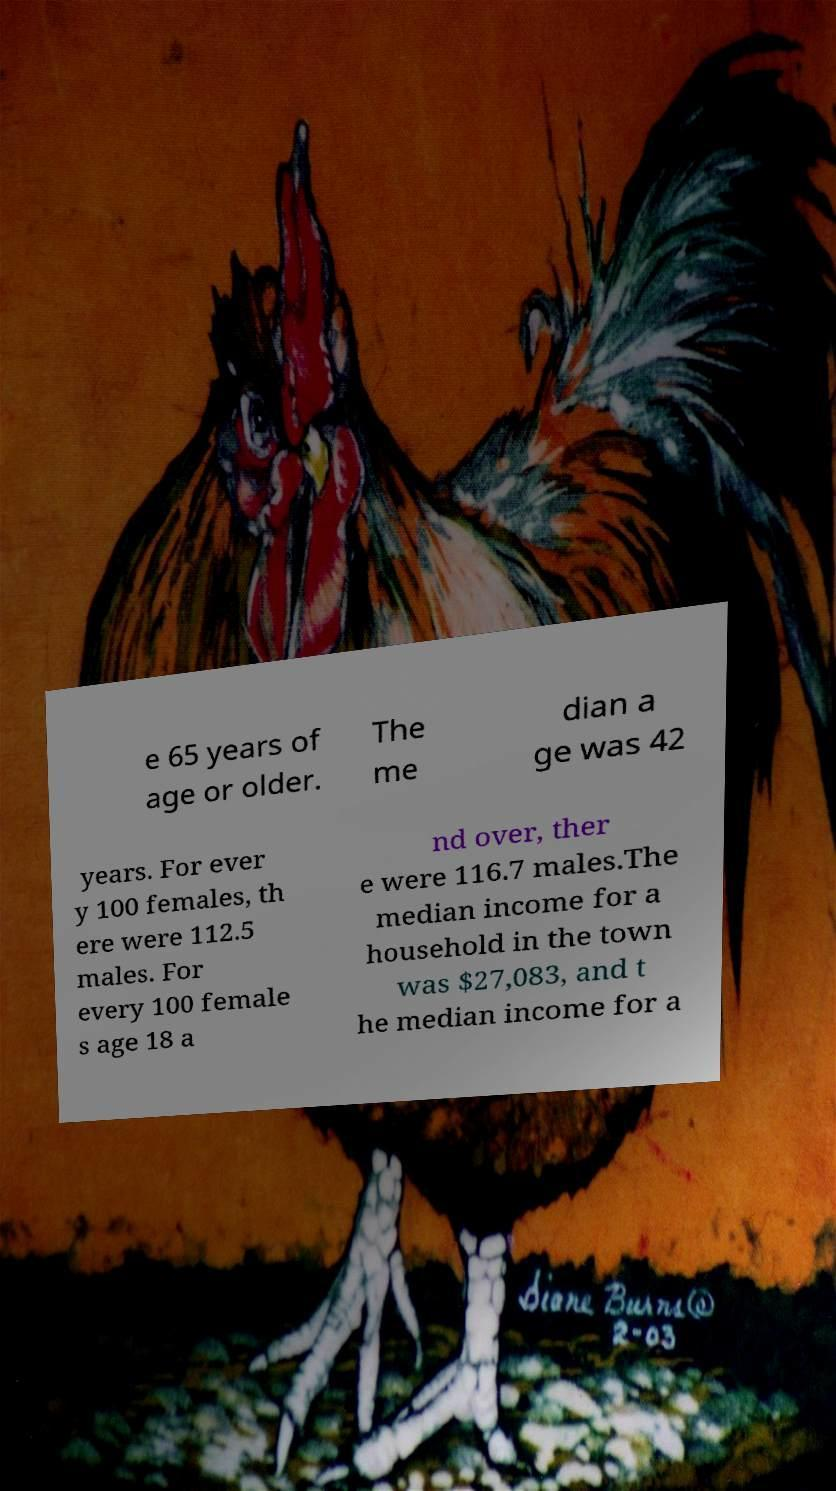Could you extract and type out the text from this image? e 65 years of age or older. The me dian a ge was 42 years. For ever y 100 females, th ere were 112.5 males. For every 100 female s age 18 a nd over, ther e were 116.7 males.The median income for a household in the town was $27,083, and t he median income for a 